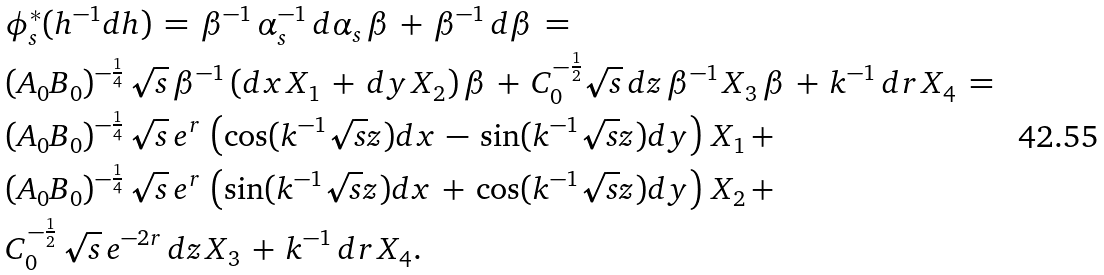Convert formula to latex. <formula><loc_0><loc_0><loc_500><loc_500>& \phi _ { s } ^ { * } ( h ^ { - 1 } d h ) \, = \, \beta ^ { - 1 } \, \alpha _ { s } ^ { - 1 } \, d \alpha _ { s } \, \beta \, + \, \beta ^ { - 1 } \, d \beta \, = \\ & ( A _ { 0 } B _ { 0 } ) ^ { - \frac { 1 } { 4 } } \, \sqrt { s } \, \beta ^ { - 1 } \, ( d x \, X _ { 1 } \, + \, d y \, X _ { 2 } ) \, \beta \, + \, C _ { 0 } ^ { - \frac { 1 } { 2 } } \sqrt { s } \, d z \, \beta ^ { - 1 } \, X _ { 3 } \, \beta \, + \, k ^ { - 1 } \, d r \, X _ { 4 } \, = \\ & ( A _ { 0 } B _ { 0 } ) ^ { - \frac { 1 } { 4 } } \, \sqrt { s } \, e ^ { r } \, \left ( \cos ( k ^ { - 1 } \sqrt { s } z ) d x \, - \, \sin ( k ^ { - 1 } \sqrt { s } z ) d y \right ) \, X _ { 1 } \, + \\ & ( A _ { 0 } B _ { 0 } ) ^ { - \frac { 1 } { 4 } } \, \sqrt { s } \, e ^ { r } \, \left ( \sin ( k ^ { - 1 } \sqrt { s } z ) d x \, + \, \cos ( k ^ { - 1 } \sqrt { s } z ) d y \right ) \, X _ { 2 } \, + \\ & C _ { 0 } ^ { - \frac { 1 } { 2 } } \, \sqrt { s } \, e ^ { - 2 r } \, d z \, X _ { 3 } \, + \, k ^ { - 1 } \, d r \, X _ { 4 } .</formula> 